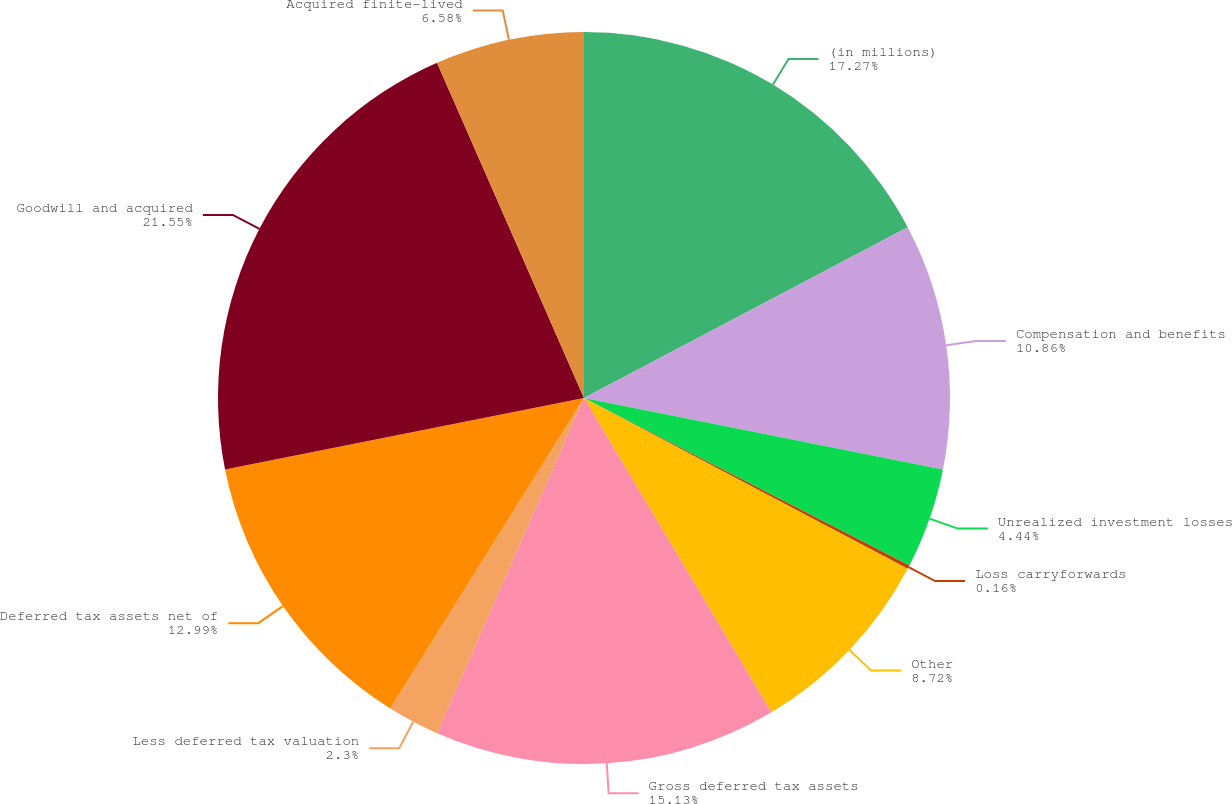Convert chart to OTSL. <chart><loc_0><loc_0><loc_500><loc_500><pie_chart><fcel>(in millions)<fcel>Compensation and benefits<fcel>Unrealized investment losses<fcel>Loss carryforwards<fcel>Other<fcel>Gross deferred tax assets<fcel>Less deferred tax valuation<fcel>Deferred tax assets net of<fcel>Goodwill and acquired<fcel>Acquired finite-lived<nl><fcel>17.28%<fcel>10.86%<fcel>4.44%<fcel>0.16%<fcel>8.72%<fcel>15.14%<fcel>2.3%<fcel>13.0%<fcel>21.56%<fcel>6.58%<nl></chart> 